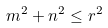Convert formula to latex. <formula><loc_0><loc_0><loc_500><loc_500>m ^ { 2 } + n ^ { 2 } \leq r ^ { 2 }</formula> 